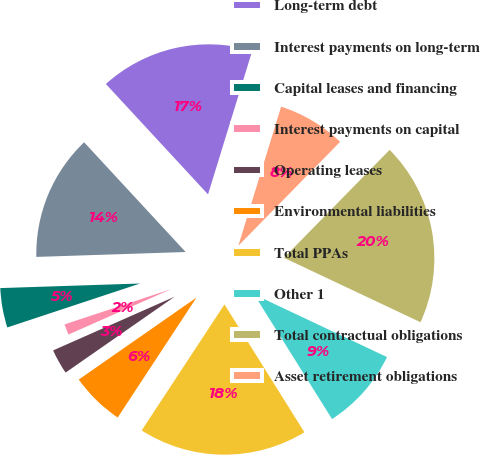<chart> <loc_0><loc_0><loc_500><loc_500><pie_chart><fcel>Long-term debt<fcel>Interest payments on long-term<fcel>Capital leases and financing<fcel>Interest payments on capital<fcel>Operating leases<fcel>Environmental liabilities<fcel>Total PPAs<fcel>Other 1<fcel>Total contractual obligations<fcel>Asset retirement obligations<nl><fcel>16.65%<fcel>13.63%<fcel>4.56%<fcel>1.54%<fcel>3.05%<fcel>6.07%<fcel>18.16%<fcel>9.09%<fcel>19.67%<fcel>7.58%<nl></chart> 